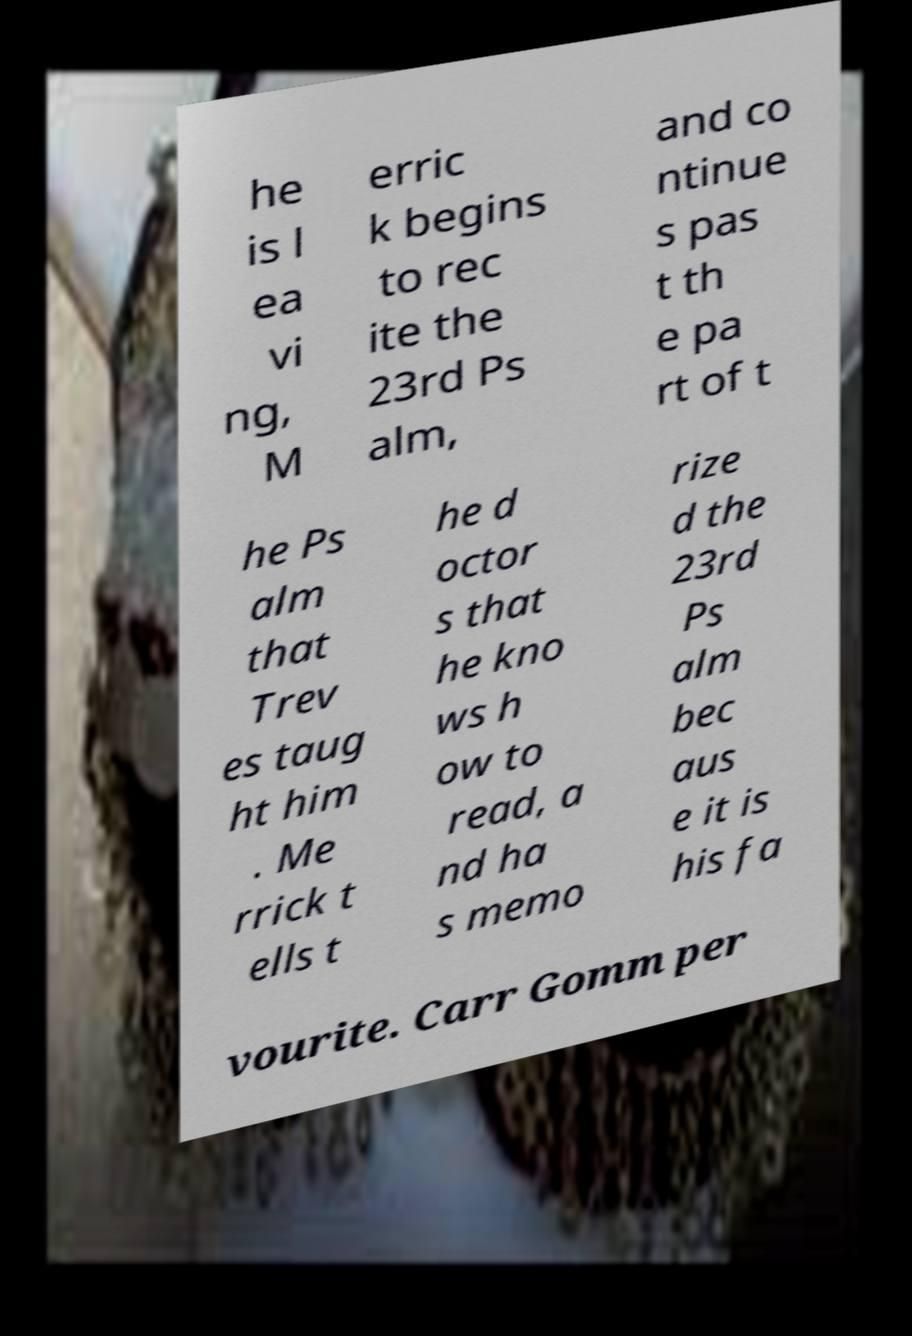I need the written content from this picture converted into text. Can you do that? he is l ea vi ng, M erric k begins to rec ite the 23rd Ps alm, and co ntinue s pas t th e pa rt of t he Ps alm that Trev es taug ht him . Me rrick t ells t he d octor s that he kno ws h ow to read, a nd ha s memo rize d the 23rd Ps alm bec aus e it is his fa vourite. Carr Gomm per 